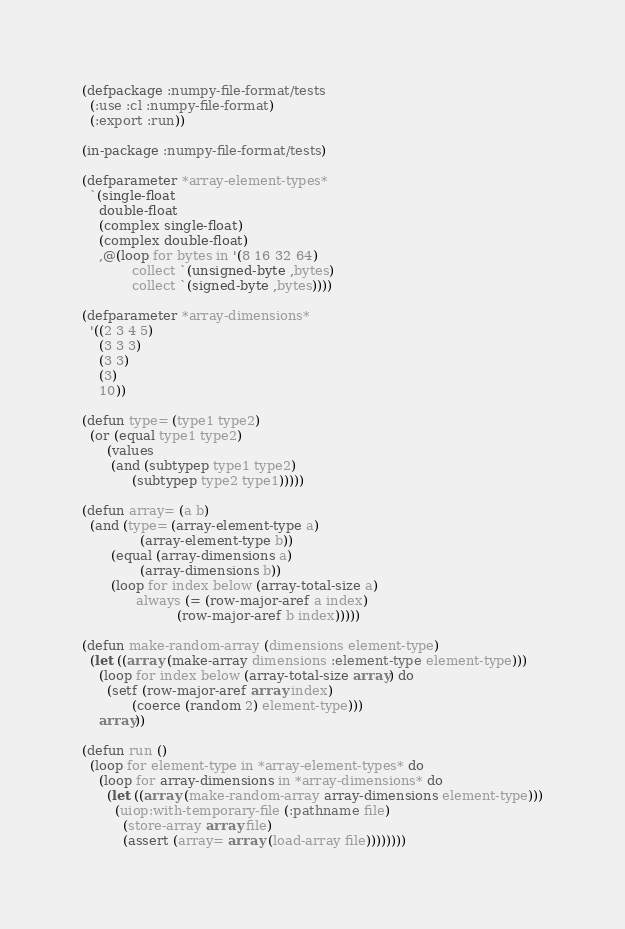<code> <loc_0><loc_0><loc_500><loc_500><_Lisp_>(defpackage :numpy-file-format/tests
  (:use :cl :numpy-file-format)
  (:export :run))

(in-package :numpy-file-format/tests)

(defparameter *array-element-types*
  `(single-float
    double-float
    (complex single-float)
    (complex double-float)
    ,@(loop for bytes in '(8 16 32 64)
            collect `(unsigned-byte ,bytes)
            collect `(signed-byte ,bytes))))

(defparameter *array-dimensions*
  '((2 3 4 5)
    (3 3 3)
    (3 3)
    (3)
    10))

(defun type= (type1 type2)
  (or (equal type1 type2)
      (values
       (and (subtypep type1 type2)
            (subtypep type2 type1)))))

(defun array= (a b)
  (and (type= (array-element-type a)
              (array-element-type b))
       (equal (array-dimensions a)
              (array-dimensions b))
       (loop for index below (array-total-size a)
             always (= (row-major-aref a index)
                       (row-major-aref b index)))))

(defun make-random-array (dimensions element-type)
  (let ((array (make-array dimensions :element-type element-type)))
    (loop for index below (array-total-size array) do
      (setf (row-major-aref array index)
            (coerce (random 2) element-type)))
    array))

(defun run ()
  (loop for element-type in *array-element-types* do
    (loop for array-dimensions in *array-dimensions* do
      (let ((array (make-random-array array-dimensions element-type)))
        (uiop:with-temporary-file (:pathname file)
          (store-array array file)
          (assert (array= array (load-array file))))))))
</code> 